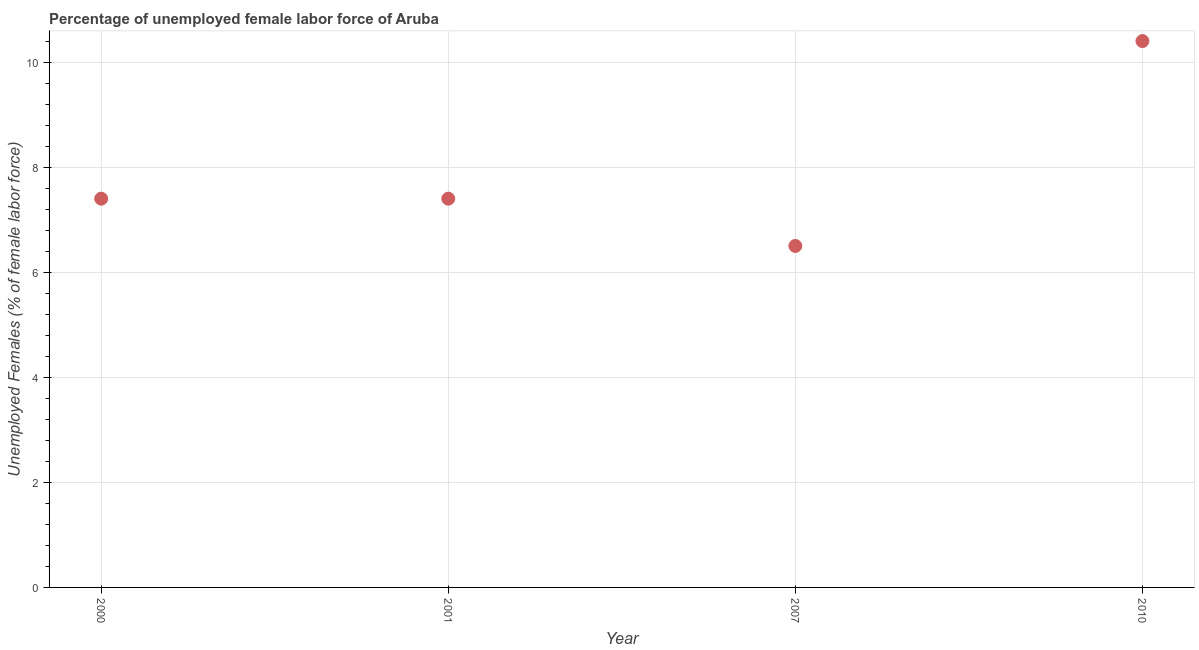What is the total unemployed female labour force in 2007?
Your answer should be very brief. 6.5. Across all years, what is the maximum total unemployed female labour force?
Your answer should be compact. 10.4. In which year was the total unemployed female labour force minimum?
Ensure brevity in your answer.  2007. What is the sum of the total unemployed female labour force?
Make the answer very short. 31.7. What is the difference between the total unemployed female labour force in 2000 and 2007?
Your answer should be very brief. 0.9. What is the average total unemployed female labour force per year?
Provide a short and direct response. 7.92. What is the median total unemployed female labour force?
Your answer should be compact. 7.4. Do a majority of the years between 2001 and 2010 (inclusive) have total unemployed female labour force greater than 9.6 %?
Keep it short and to the point. No. What is the ratio of the total unemployed female labour force in 2000 to that in 2007?
Your answer should be compact. 1.14. Is the total unemployed female labour force in 2000 less than that in 2007?
Offer a very short reply. No. Is the difference between the total unemployed female labour force in 2001 and 2010 greater than the difference between any two years?
Provide a succinct answer. No. What is the difference between the highest and the second highest total unemployed female labour force?
Make the answer very short. 3. Is the sum of the total unemployed female labour force in 2000 and 2007 greater than the maximum total unemployed female labour force across all years?
Ensure brevity in your answer.  Yes. What is the difference between the highest and the lowest total unemployed female labour force?
Make the answer very short. 3.9. Does the graph contain any zero values?
Keep it short and to the point. No. Does the graph contain grids?
Give a very brief answer. Yes. What is the title of the graph?
Keep it short and to the point. Percentage of unemployed female labor force of Aruba. What is the label or title of the Y-axis?
Your answer should be very brief. Unemployed Females (% of female labor force). What is the Unemployed Females (% of female labor force) in 2000?
Your answer should be compact. 7.4. What is the Unemployed Females (% of female labor force) in 2001?
Your response must be concise. 7.4. What is the Unemployed Females (% of female labor force) in 2007?
Provide a succinct answer. 6.5. What is the Unemployed Females (% of female labor force) in 2010?
Offer a very short reply. 10.4. What is the difference between the Unemployed Females (% of female labor force) in 2000 and 2007?
Your answer should be very brief. 0.9. What is the difference between the Unemployed Females (% of female labor force) in 2000 and 2010?
Your answer should be very brief. -3. What is the difference between the Unemployed Females (% of female labor force) in 2001 and 2007?
Your answer should be compact. 0.9. What is the difference between the Unemployed Females (% of female labor force) in 2007 and 2010?
Make the answer very short. -3.9. What is the ratio of the Unemployed Females (% of female labor force) in 2000 to that in 2007?
Keep it short and to the point. 1.14. What is the ratio of the Unemployed Females (% of female labor force) in 2000 to that in 2010?
Make the answer very short. 0.71. What is the ratio of the Unemployed Females (% of female labor force) in 2001 to that in 2007?
Ensure brevity in your answer.  1.14. What is the ratio of the Unemployed Females (% of female labor force) in 2001 to that in 2010?
Give a very brief answer. 0.71. 